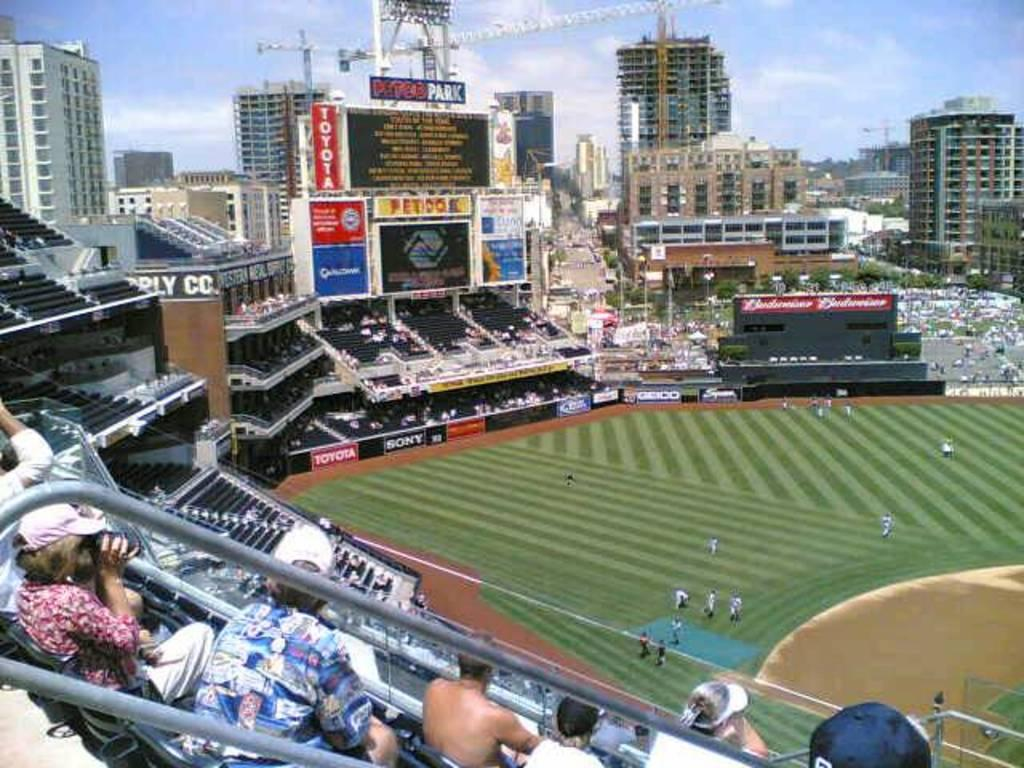What is the main subject in the middle of the picture? There is a playground in the middle of the picture. What other structure can be seen in the picture? There is a stadium in the picture. What can be seen in the background of the picture? There are buildings and clouds in the sky in the background of the picture. Can you tell me which guide is leading the group of people towards the base in the picture? There is no guide or group of people present in the image, nor is there a base. 